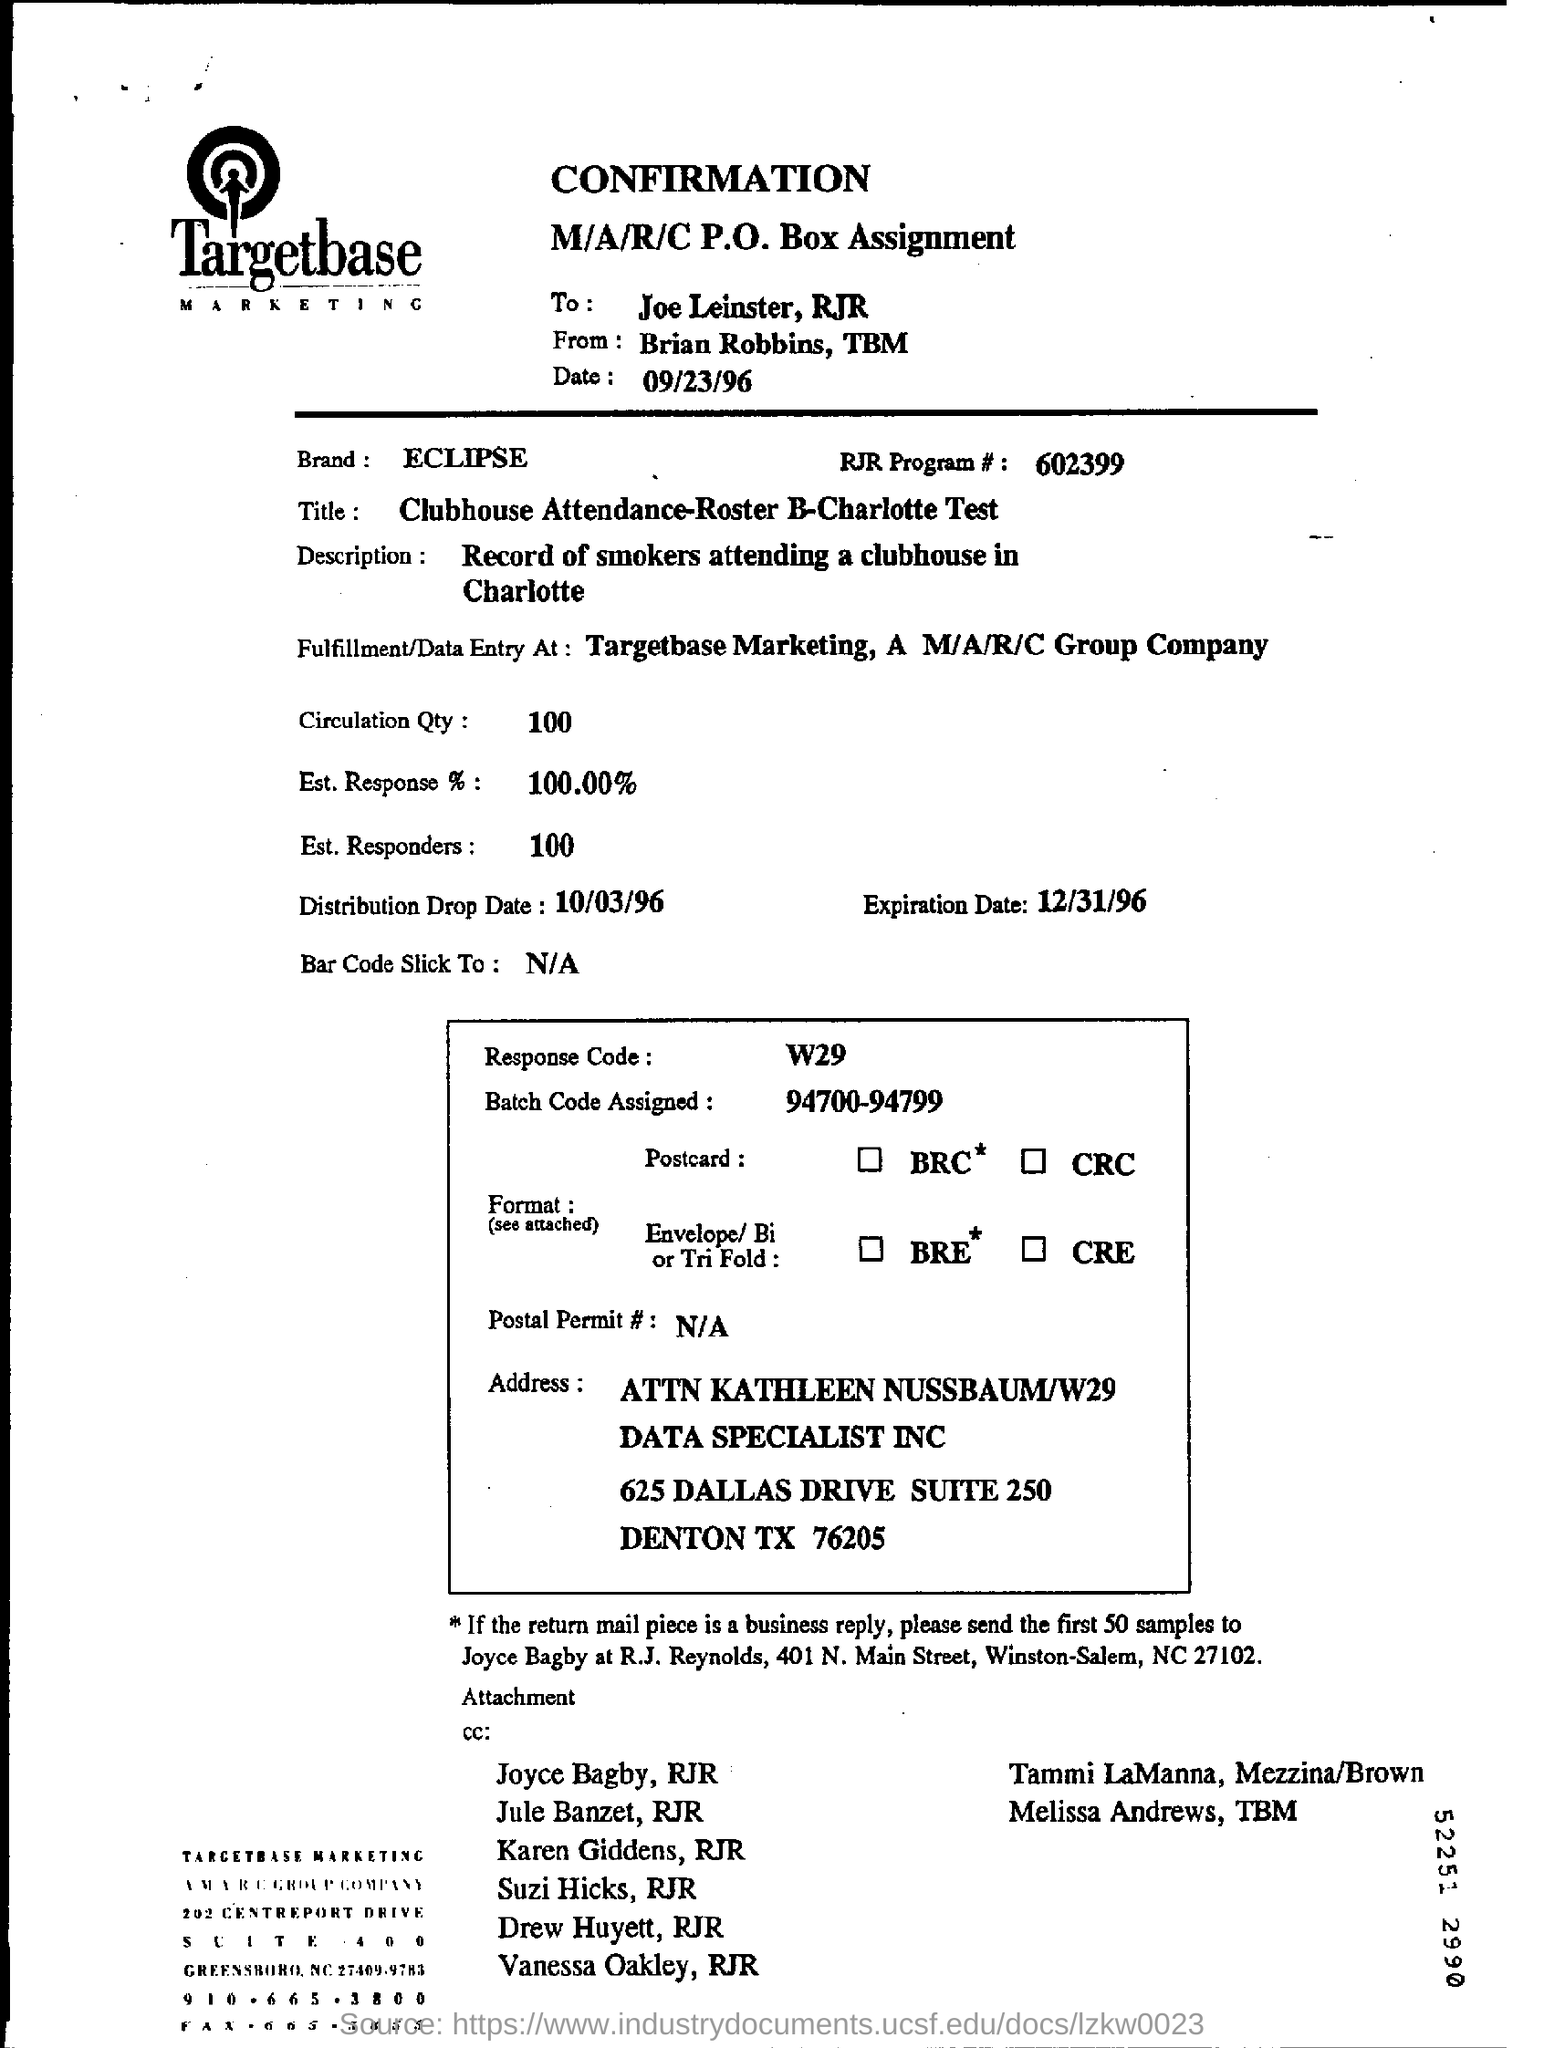Point out several critical features in this image. The estimated response is 100.00. What is the date of expiration for December 31, 1996? The RJR program number is 602399... Marketing is the name of a process that involves identifying and reaching a specific target audience through the utilization of various strategies and techniques, as exemplified by the term "Targetbase. 